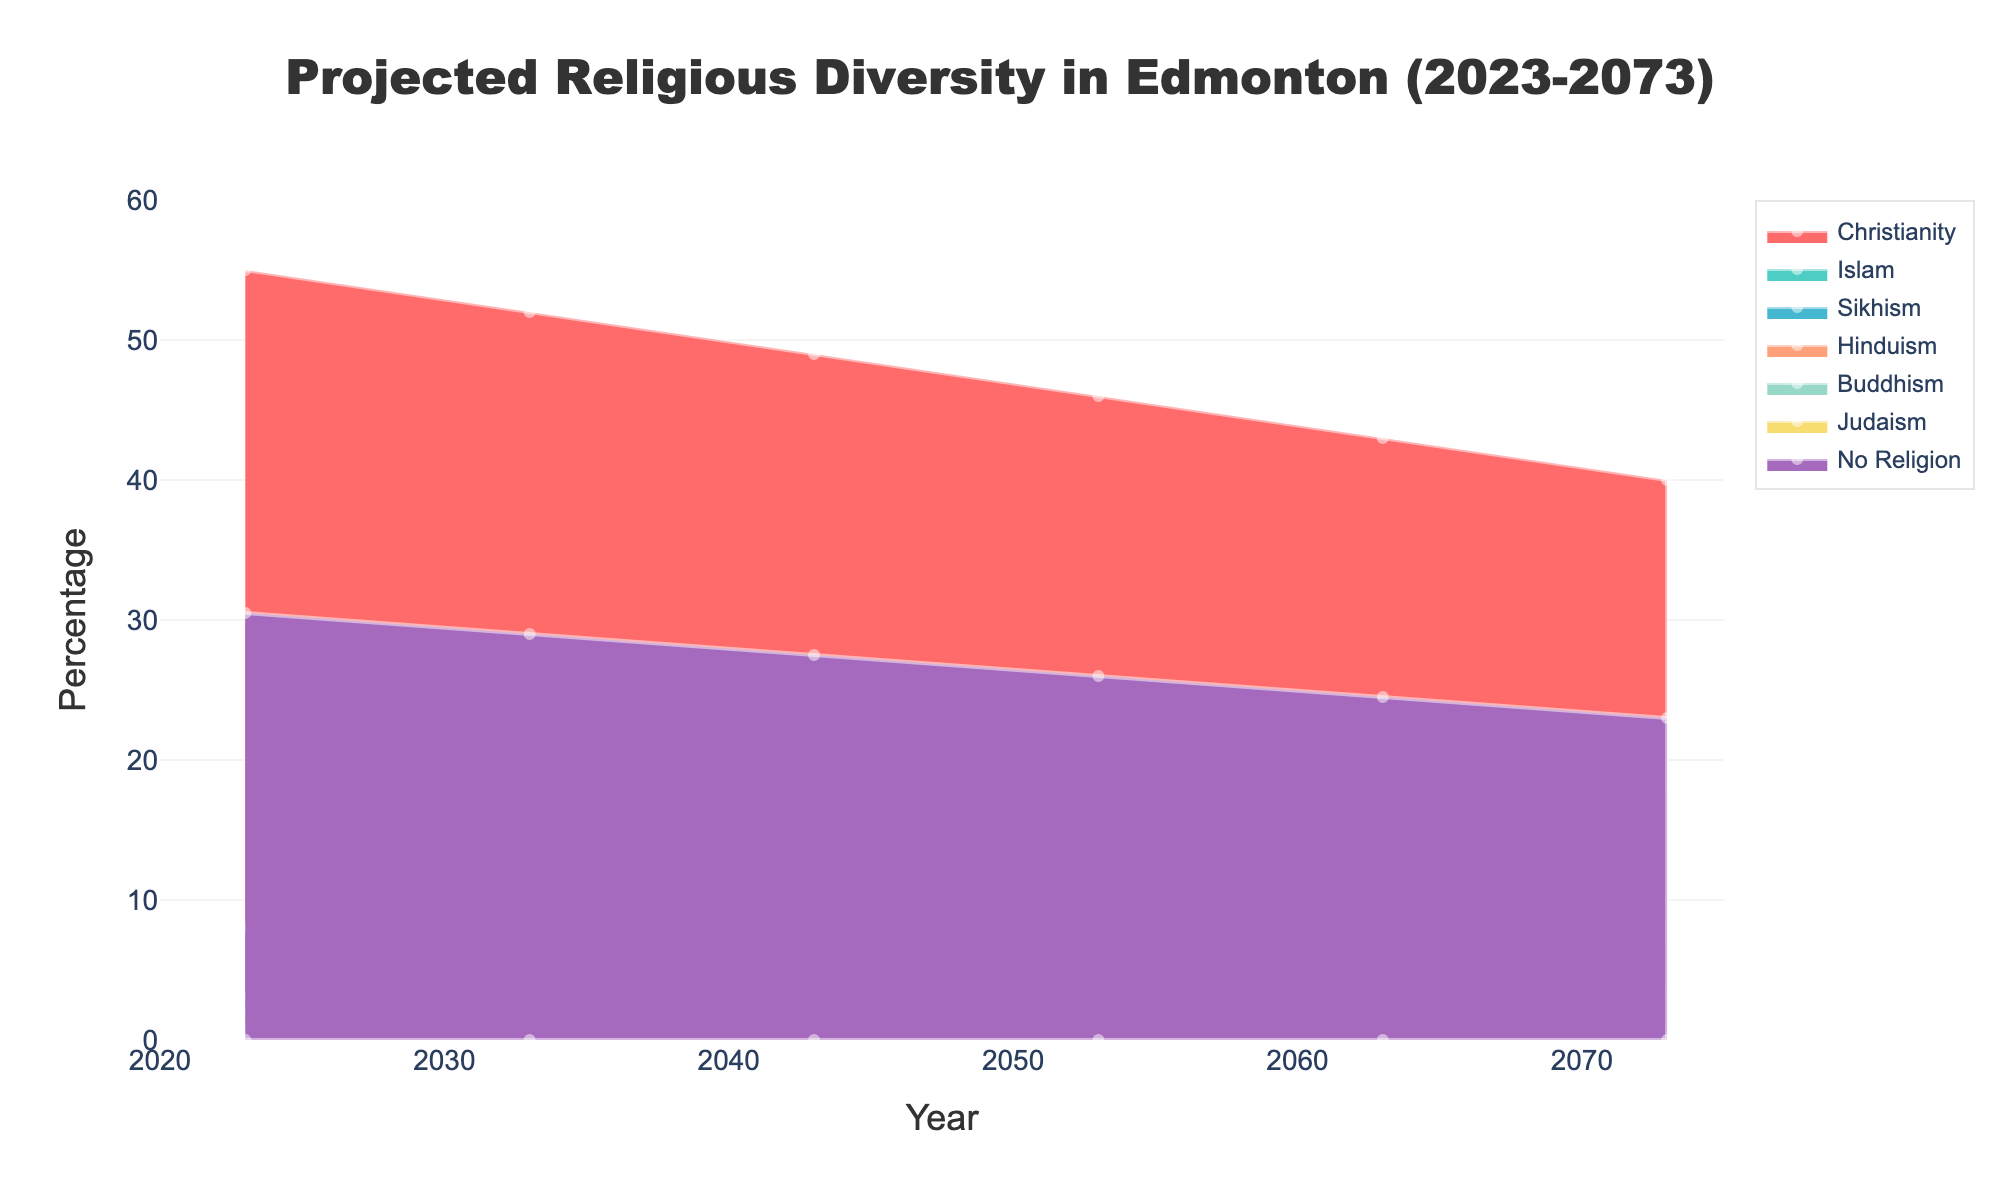What is the title of the fan chart? The title is located at the top center of the figure and it depicts the overall subject of the chart.
Answer: Projected Religious Diversity in Edmonton (2023-2073) What is the expected percentage of people identifying as Christian in 2053? Look at the intersection of the Christianity line and the year 2053 on the horizontal axis.
Answer: 46% How does the percentage of people with no religion change from 2023 to 2073? Compare the value of "No Religion" in 2023 and 2073 from the chart. The percentage decreases from 30.5% in 2023 to 23% in 2073.
Answer: It decreases by 7.5% Which religion shows the highest growth percentage over the 50-year period? Calculate the difference in percentage for each religion between 2023 and 2073. Identify the religion with the largest increase. Islam grows from 8% to 18%, which is the highest increase by 10%.
Answer: Islam What is the projected percentage of Hindus in 2063? Locate the value for Hinduism at the year 2063 along the horizontal axis.
Answer: 6% Which religion is projected to have the smallest percentage in 2073? Compare the values of all religions for the year 2073 on the chart. Judaism remains at a constant 0.5%, which is the smallest percentage.
Answer: Judaism By what percentage does the Sikhism population increase between 2023 and 2073? Subtract the percentage of Sikhism in 2023 from its percentage in 2073.
Answer: 8% - 3% = 5% How does the combined percentage of minority religions (Islam, Sikhism, Hinduism, Buddhism, Judaism) in 2023 compare to the combined percentage in 2073? Sum the percentages of Islam, Sikhism, Hinduism, Buddhism, and Judaism for 2023 and 2073 and compare the totals. In 2023: 8 + 3 + 2 + 1 + 0.5 = 14.5%; in 2073: 18 + 8 + 7 + 3.5 + 0.5 = 37%.
Answer: 14.5% versus 37% Which two religions see the most similar growth trajectory over the 50 years? Observe the chart and compare the growth curves of each religion to identify two with similar trends. Hinduism and Buddhism have relatively parallel growth lines, both starting small and growing steadily.
Answer: Hinduism and Buddhism Around which year do Islam and Christianity percentages intersect, if ever? Look at where the lines for Islam and Christianity would potentially intersect on the chart. They do not intersect but get closest around 2073, where Islam is at 18% and Christianity is at 40%.
Answer: They do not intersect 